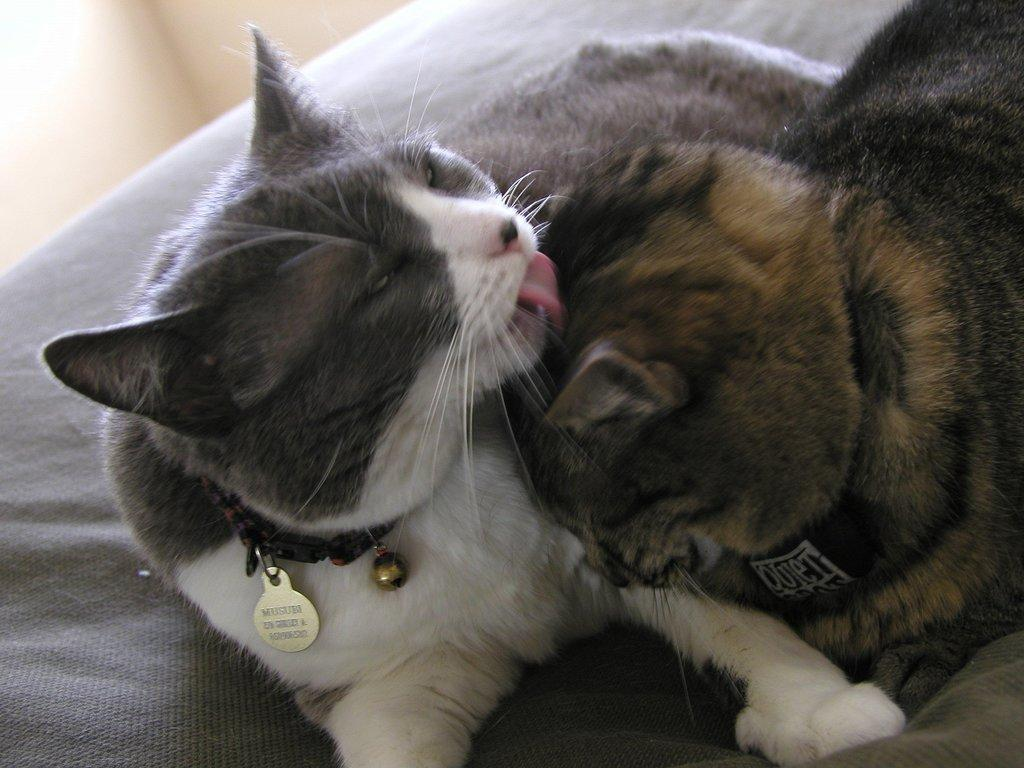What animal is present in the image? There is a cat in the image. What is the cat doing in the image? The cat is licking the head of another cat. What type of hair is being distributed by the cat in the image? There is no hair being distributed by the cat in the image; the cat is licking the head of another cat. 